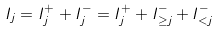Convert formula to latex. <formula><loc_0><loc_0><loc_500><loc_500>I _ { j } = I ^ { + } _ { j } + I ^ { - } _ { j } = I ^ { + } _ { j } + I ^ { - } _ { \geq j } + I ^ { - } _ { < j }</formula> 